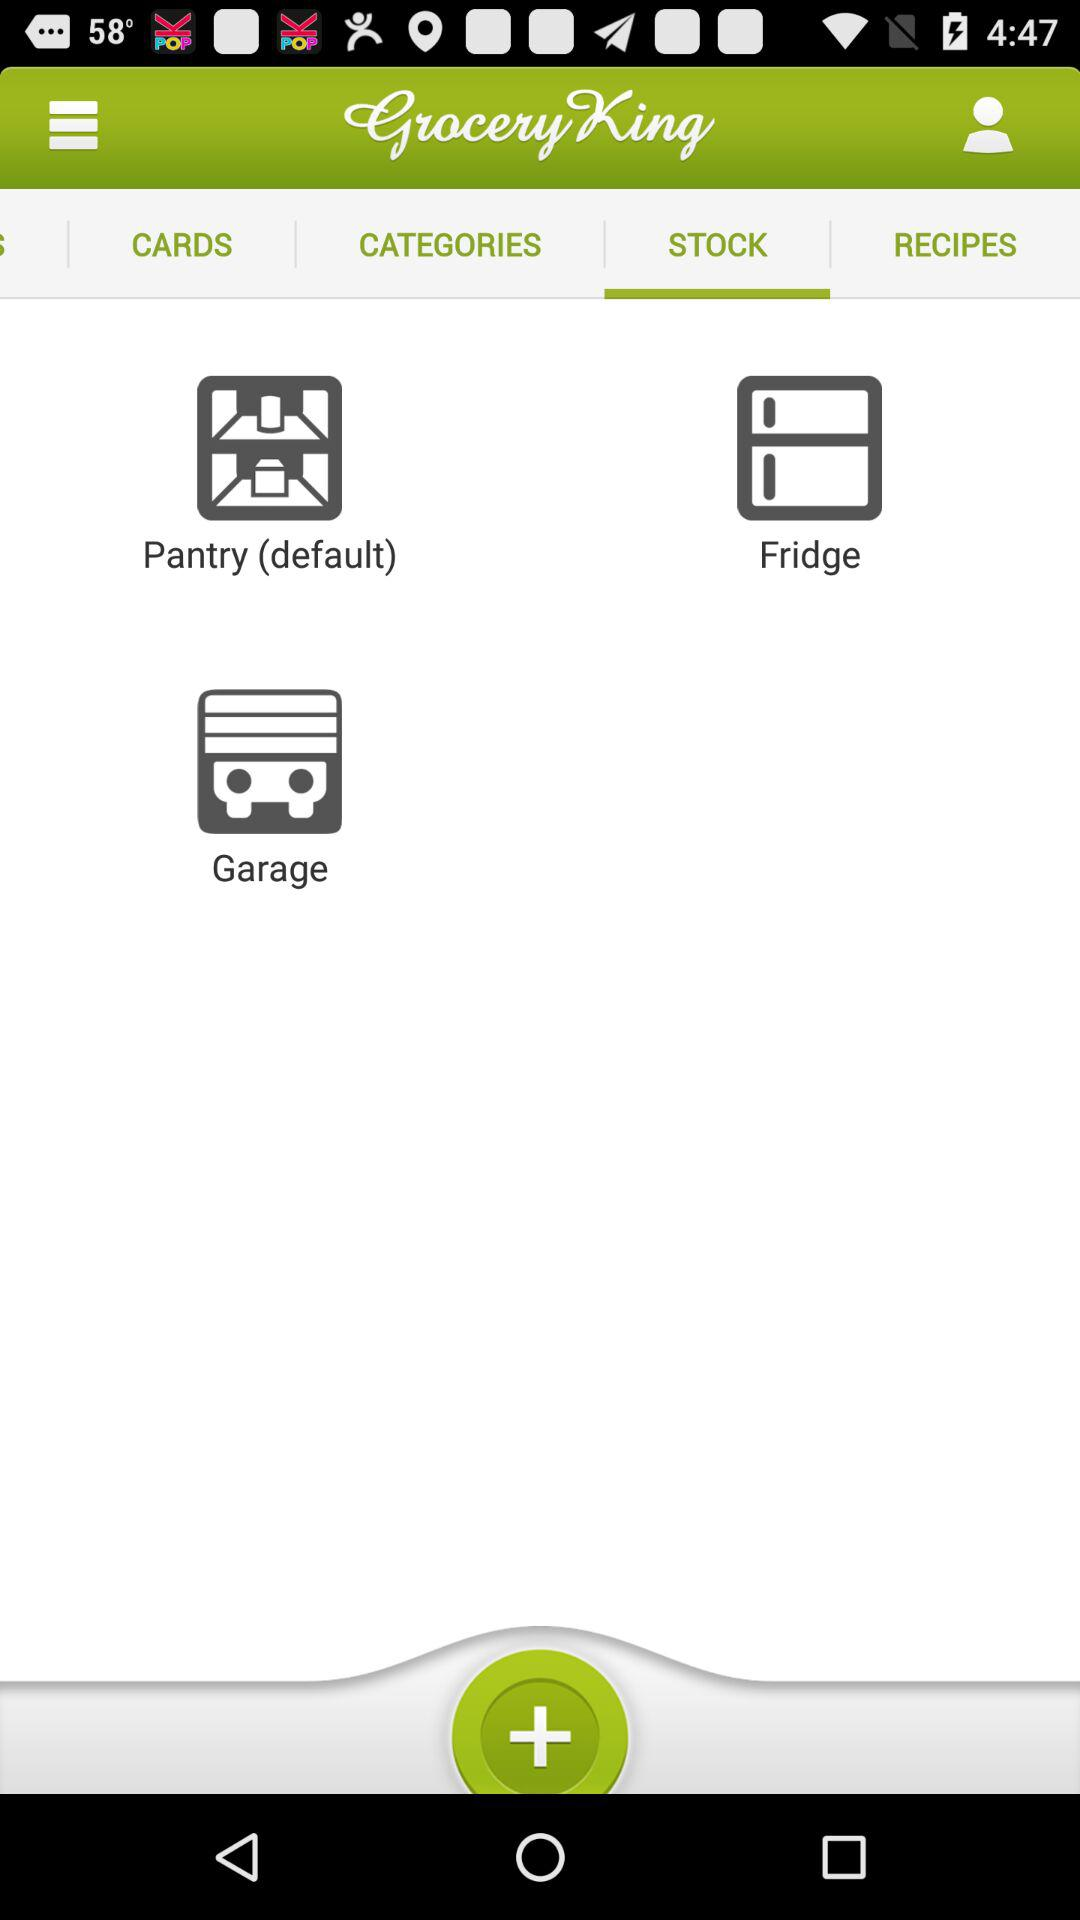What is the selected tab? The selected tab is "STOCK". 